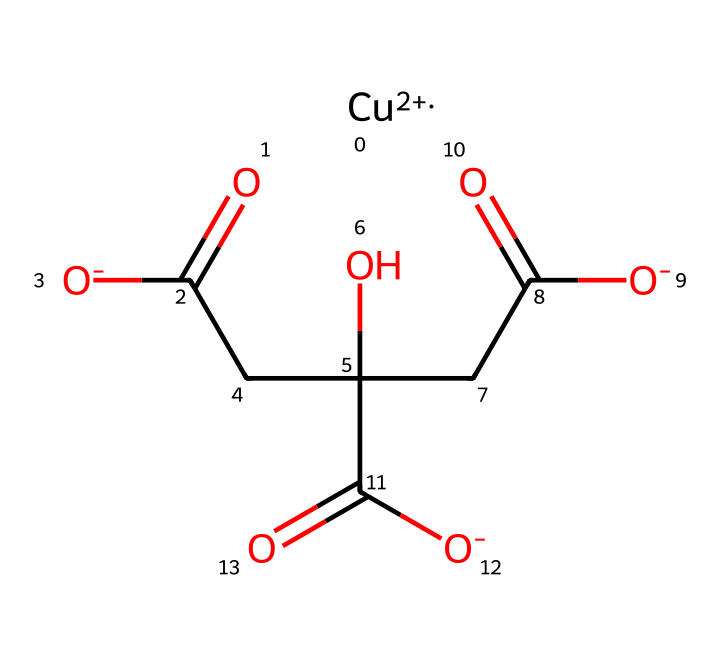What is the central metal ion in this coordination compound? The compound contains a copper ion denoted as Cu+2 in the SMILES representation, signifying it is the central metal ion.
Answer: copper How many carboxylate groups are present in this structure? Upon inspection of the chemical structure, three carboxylate groups are indicated, which correspond to the components with the formula CC(O)(CC([O-])=O)C([O-])=O. Each carboxylate is identified as -COO-.
Answer: three What is the oxidation state of copper in this complex? The SMILES notation specifies '[Cu+2]', indicating that copper is in the +2 oxidation state within the coordination complex.
Answer: +2 Which type of ligands are coordinating to the copper ion? The chemical features several carboxylate ligands coordinated to the copper ion, represented by the carboxylic acid functional groups within the structure.
Answer: carboxylate What type of coordination geometry is expected for this complex? Given the presence of one copper ion and the surrounding carboxylate groups, the geometry is likely to be octahedral, which is common for copper(II) complexes with this number of ligands.
Answer: octahedral How many total oxygen atoms are present in the compound? The structure contains a total of 6 oxygen atoms: three from the carboxylate groups and three from the other -OH groups present in the citrate framework.
Answer: six 